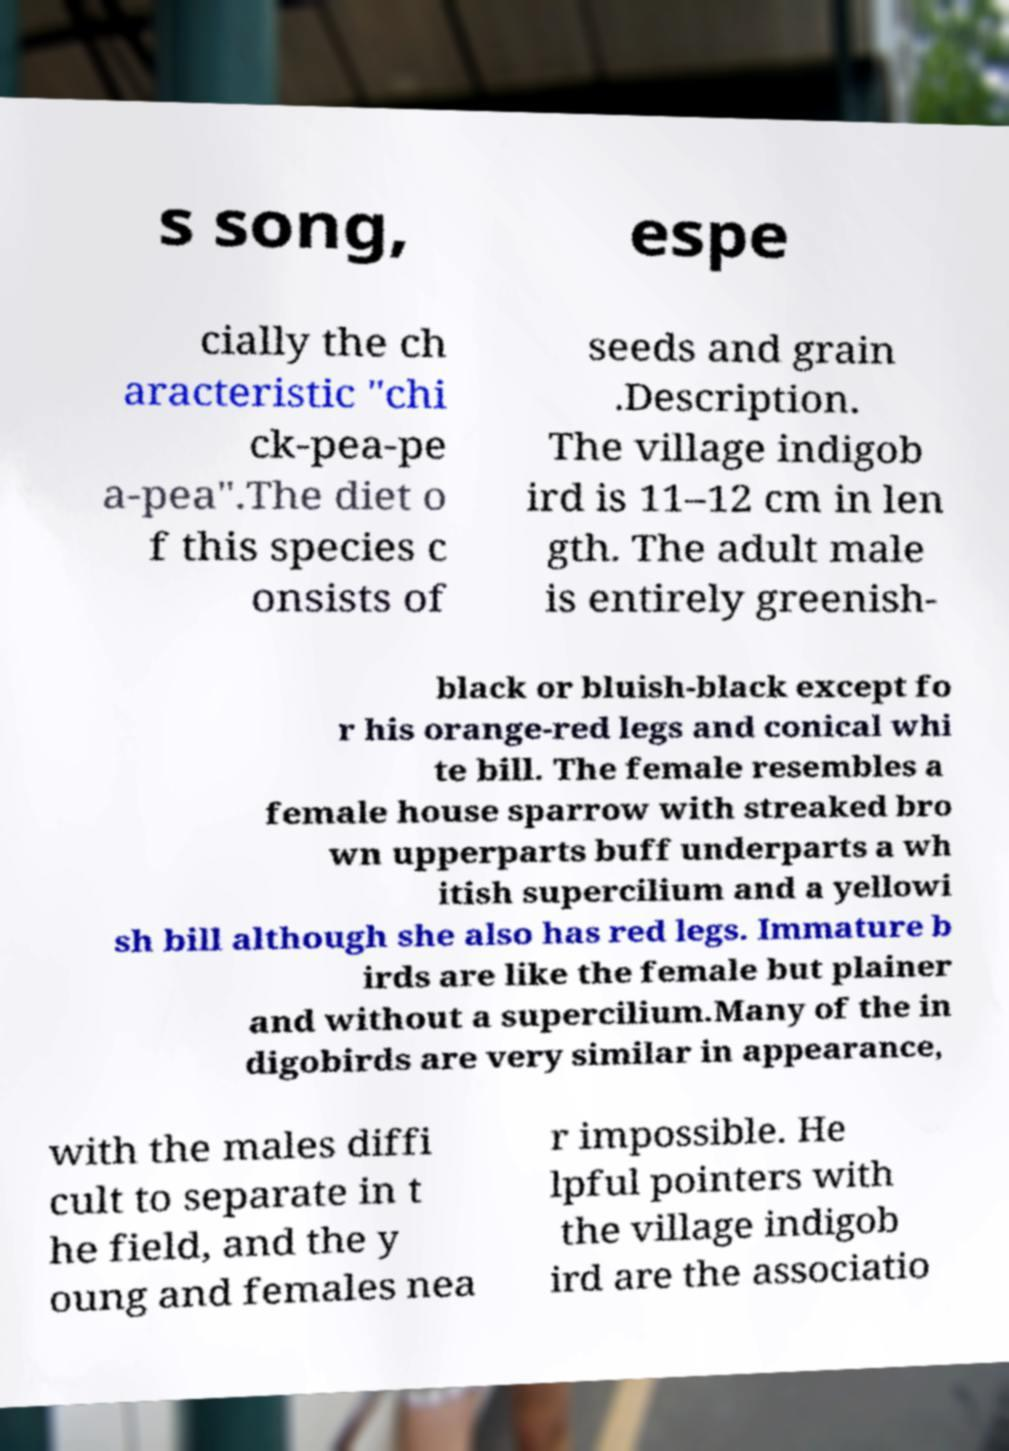Please identify and transcribe the text found in this image. s song, espe cially the ch aracteristic "chi ck-pea-pe a-pea".The diet o f this species c onsists of seeds and grain .Description. The village indigob ird is 11–12 cm in len gth. The adult male is entirely greenish- black or bluish-black except fo r his orange-red legs and conical whi te bill. The female resembles a female house sparrow with streaked bro wn upperparts buff underparts a wh itish supercilium and a yellowi sh bill although she also has red legs. Immature b irds are like the female but plainer and without a supercilium.Many of the in digobirds are very similar in appearance, with the males diffi cult to separate in t he field, and the y oung and females nea r impossible. He lpful pointers with the village indigob ird are the associatio 